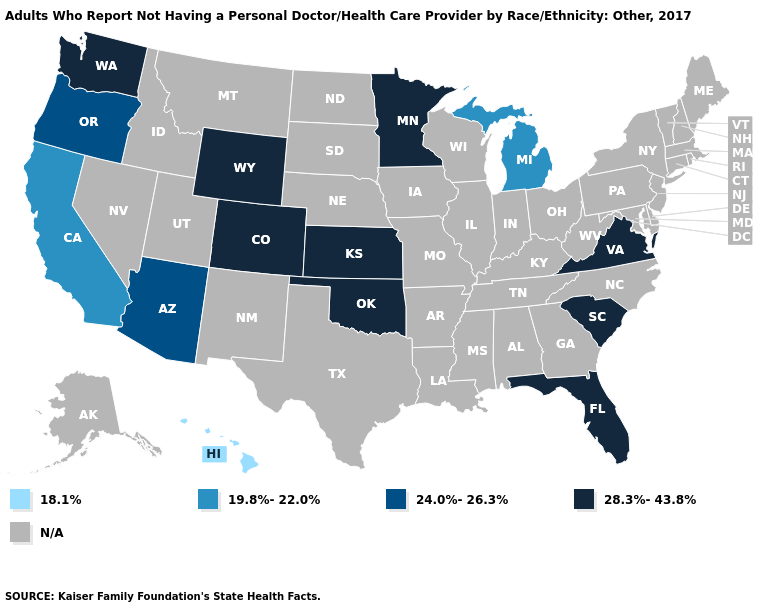What is the value of Alaska?
Be succinct. N/A. What is the highest value in the USA?
Answer briefly. 28.3%-43.8%. Does the first symbol in the legend represent the smallest category?
Quick response, please. Yes. Does the first symbol in the legend represent the smallest category?
Keep it brief. Yes. Does Oregon have the highest value in the USA?
Write a very short answer. No. What is the value of Virginia?
Give a very brief answer. 28.3%-43.8%. What is the value of Maine?
Concise answer only. N/A. Does the map have missing data?
Be succinct. Yes. Does Hawaii have the lowest value in the USA?
Keep it brief. Yes. Name the states that have a value in the range 28.3%-43.8%?
Short answer required. Colorado, Florida, Kansas, Minnesota, Oklahoma, South Carolina, Virginia, Washington, Wyoming. What is the highest value in the West ?
Be succinct. 28.3%-43.8%. Is the legend a continuous bar?
Short answer required. No. Name the states that have a value in the range N/A?
Keep it brief. Alabama, Alaska, Arkansas, Connecticut, Delaware, Georgia, Idaho, Illinois, Indiana, Iowa, Kentucky, Louisiana, Maine, Maryland, Massachusetts, Mississippi, Missouri, Montana, Nebraska, Nevada, New Hampshire, New Jersey, New Mexico, New York, North Carolina, North Dakota, Ohio, Pennsylvania, Rhode Island, South Dakota, Tennessee, Texas, Utah, Vermont, West Virginia, Wisconsin. What is the value of West Virginia?
Concise answer only. N/A. 